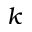Convert formula to latex. <formula><loc_0><loc_0><loc_500><loc_500>k</formula> 